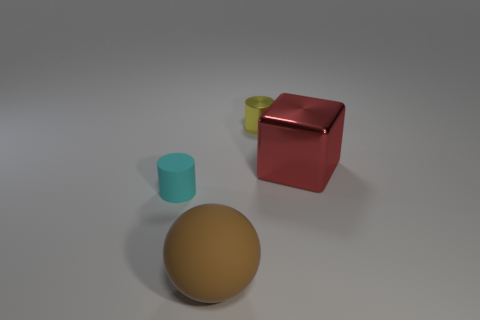Are there any other things that have the same shape as the big red shiny thing?
Your answer should be very brief. No. There is a rubber object behind the matte thing that is right of the cyan thing to the left of the large red metallic cube; what is its color?
Ensure brevity in your answer.  Cyan. Is the material of the yellow cylinder the same as the big red block?
Your answer should be very brief. Yes. There is a metallic cube; how many large things are to the right of it?
Make the answer very short. 0. What size is the matte object that is the same shape as the tiny metallic object?
Offer a terse response. Small. How many cyan things are large blocks or tiny matte cylinders?
Your answer should be compact. 1. There is a small matte object behind the large rubber sphere; what number of things are to the right of it?
Provide a succinct answer. 3. How many other objects are the same shape as the red metal thing?
Make the answer very short. 0. How many big rubber objects are the same color as the rubber sphere?
Make the answer very short. 0. What color is the small cylinder that is the same material as the red cube?
Your answer should be compact. Yellow. 